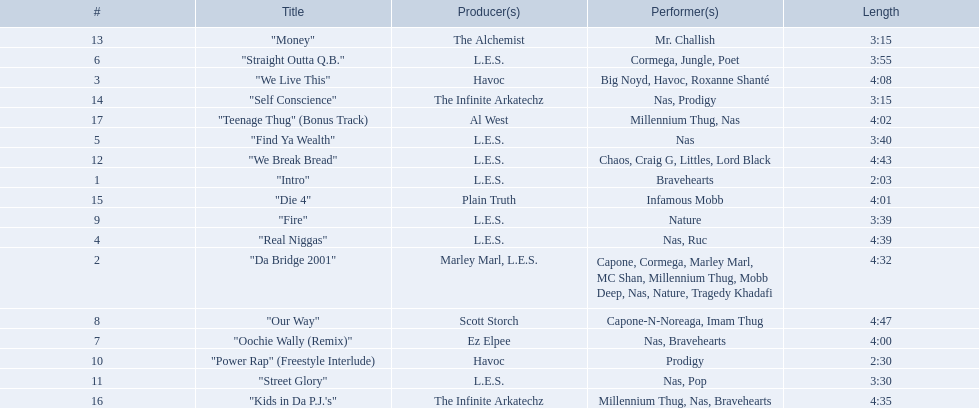How long is each song? 2:03, 4:32, 4:08, 4:39, 3:40, 3:55, 4:00, 4:47, 3:39, 2:30, 3:30, 4:43, 3:15, 3:15, 4:01, 4:35, 4:02. What length is the longest? 4:47. 